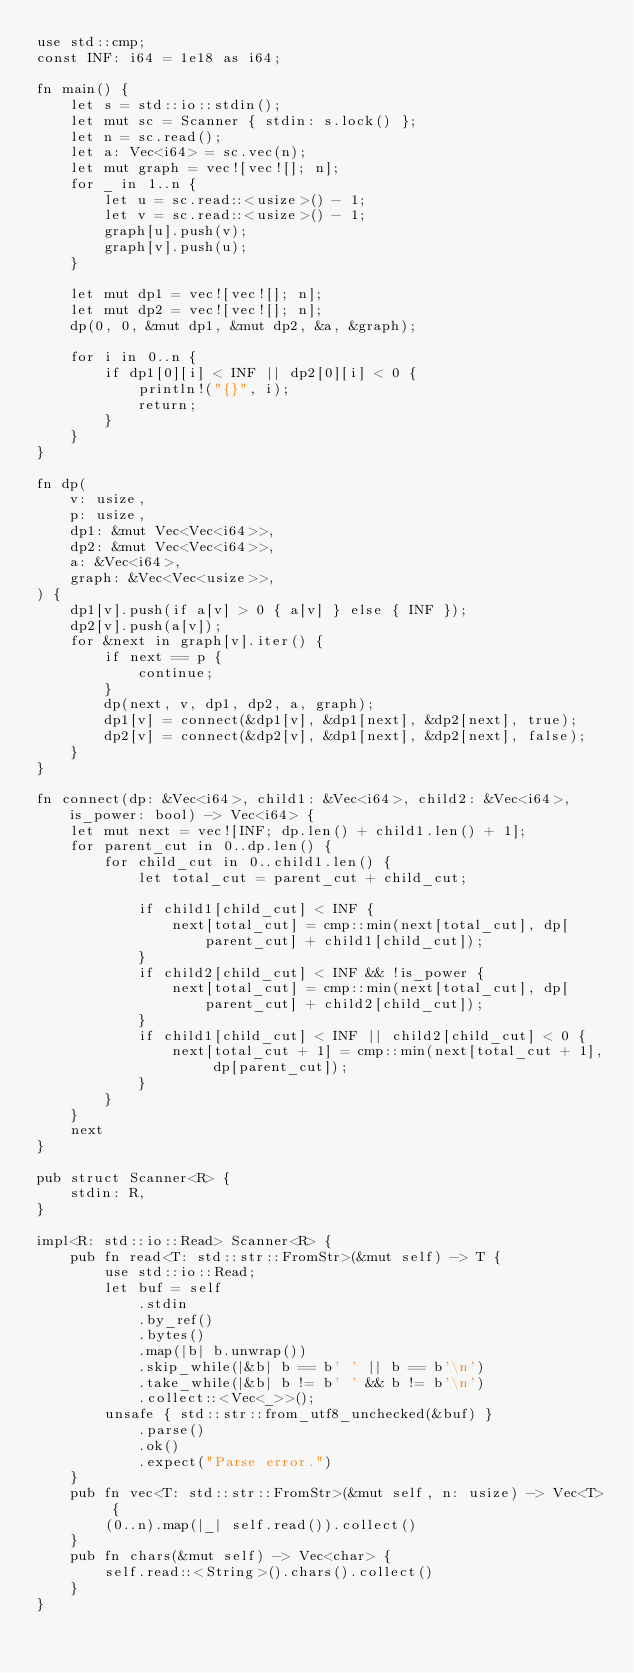<code> <loc_0><loc_0><loc_500><loc_500><_Rust_>use std::cmp;
const INF: i64 = 1e18 as i64;

fn main() {
    let s = std::io::stdin();
    let mut sc = Scanner { stdin: s.lock() };
    let n = sc.read();
    let a: Vec<i64> = sc.vec(n);
    let mut graph = vec![vec![]; n];
    for _ in 1..n {
        let u = sc.read::<usize>() - 1;
        let v = sc.read::<usize>() - 1;
        graph[u].push(v);
        graph[v].push(u);
    }

    let mut dp1 = vec![vec![]; n];
    let mut dp2 = vec![vec![]; n];
    dp(0, 0, &mut dp1, &mut dp2, &a, &graph);

    for i in 0..n {
        if dp1[0][i] < INF || dp2[0][i] < 0 {
            println!("{}", i);
            return;
        }
    }
}

fn dp(
    v: usize,
    p: usize,
    dp1: &mut Vec<Vec<i64>>,
    dp2: &mut Vec<Vec<i64>>,
    a: &Vec<i64>,
    graph: &Vec<Vec<usize>>,
) {
    dp1[v].push(if a[v] > 0 { a[v] } else { INF });
    dp2[v].push(a[v]);
    for &next in graph[v].iter() {
        if next == p {
            continue;
        }
        dp(next, v, dp1, dp2, a, graph);
        dp1[v] = connect(&dp1[v], &dp1[next], &dp2[next], true);
        dp2[v] = connect(&dp2[v], &dp1[next], &dp2[next], false);
    }
}

fn connect(dp: &Vec<i64>, child1: &Vec<i64>, child2: &Vec<i64>, is_power: bool) -> Vec<i64> {
    let mut next = vec![INF; dp.len() + child1.len() + 1];
    for parent_cut in 0..dp.len() {
        for child_cut in 0..child1.len() {
            let total_cut = parent_cut + child_cut;

            if child1[child_cut] < INF {
                next[total_cut] = cmp::min(next[total_cut], dp[parent_cut] + child1[child_cut]);
            }
            if child2[child_cut] < INF && !is_power {
                next[total_cut] = cmp::min(next[total_cut], dp[parent_cut] + child2[child_cut]);
            }
            if child1[child_cut] < INF || child2[child_cut] < 0 {
                next[total_cut + 1] = cmp::min(next[total_cut + 1], dp[parent_cut]);
            }
        }
    }
    next
}

pub struct Scanner<R> {
    stdin: R,
}

impl<R: std::io::Read> Scanner<R> {
    pub fn read<T: std::str::FromStr>(&mut self) -> T {
        use std::io::Read;
        let buf = self
            .stdin
            .by_ref()
            .bytes()
            .map(|b| b.unwrap())
            .skip_while(|&b| b == b' ' || b == b'\n')
            .take_while(|&b| b != b' ' && b != b'\n')
            .collect::<Vec<_>>();
        unsafe { std::str::from_utf8_unchecked(&buf) }
            .parse()
            .ok()
            .expect("Parse error.")
    }
    pub fn vec<T: std::str::FromStr>(&mut self, n: usize) -> Vec<T> {
        (0..n).map(|_| self.read()).collect()
    }
    pub fn chars(&mut self) -> Vec<char> {
        self.read::<String>().chars().collect()
    }
}
</code> 